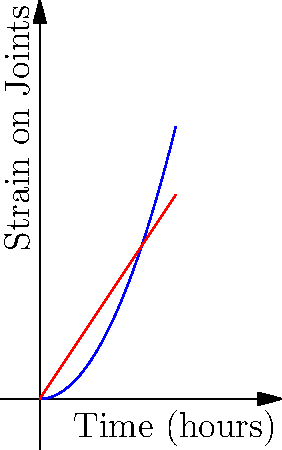Based on the graph showing the relationship between time spent creating art and strain on joints, which technique (traditional or digital) appears to cause more strain on the artist's joints over extended periods of time, and why might this be significant for long-term health considerations in the art community? To answer this question, let's analyze the graph step-by-step:

1. The blue curve represents traditional art techniques, while the red line represents digital art techniques.

2. The x-axis shows time spent creating art in hours, and the y-axis represents strain on joints.

3. Traditional art (blue curve):
   - The curve is parabolic ($$y = 0.5x^2$$), indicating an accelerating increase in joint strain over time.
   - As time increases, the strain on joints increases at a faster rate.

4. Digital art (red line):
   - The line is straight ($$y = 1.5x$$), showing a constant rate of increase in joint strain over time.

5. Comparing the two:
   - For shorter periods (roughly up to 3 hours), digital art causes more strain.
   - However, beyond this point, traditional art techniques start to cause more strain, and the difference increases rapidly.

6. Long-term health considerations:
   - The accelerating nature of joint strain in traditional art suggests a higher risk of repetitive stress injuries or chronic conditions over extended periods.
   - This is significant for the art community as it highlights the importance of ergonomics and proper techniques in traditional art practices.
   - It also suggests that alternating between traditional and digital techniques might be beneficial for artists' long-term joint health.
Answer: Traditional art causes more joint strain over extended periods, potentially increasing the risk of long-term repetitive stress injuries. 